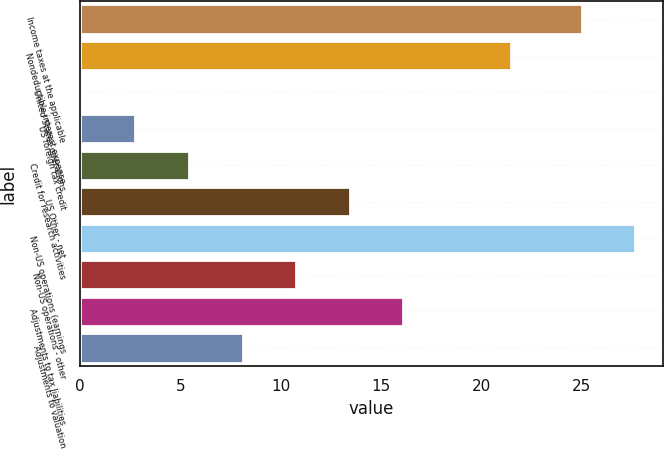<chart> <loc_0><loc_0><loc_500><loc_500><bar_chart><fcel>Income taxes at the applicable<fcel>Nondeductible interest expense<fcel>United States operations<fcel>US foreign tax credit<fcel>Credit for research activities<fcel>US Other - net<fcel>Non-US operations (earnings<fcel>Non-US operations - other<fcel>Adjustments to tax liabilities<fcel>Adjustments to valuation<nl><fcel>25<fcel>21.46<fcel>0.1<fcel>2.77<fcel>5.44<fcel>13.45<fcel>27.67<fcel>10.78<fcel>16.12<fcel>8.11<nl></chart> 